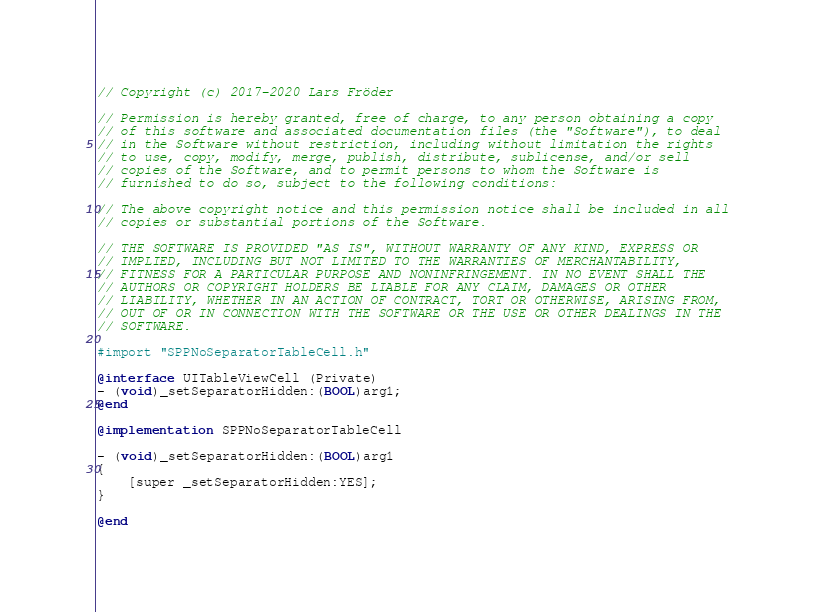Convert code to text. <code><loc_0><loc_0><loc_500><loc_500><_ObjectiveC_>// Copyright (c) 2017-2020 Lars Fröder

// Permission is hereby granted, free of charge, to any person obtaining a copy
// of this software and associated documentation files (the "Software"), to deal
// in the Software without restriction, including without limitation the rights
// to use, copy, modify, merge, publish, distribute, sublicense, and/or sell
// copies of the Software, and to permit persons to whom the Software is
// furnished to do so, subject to the following conditions:

// The above copyright notice and this permission notice shall be included in all
// copies or substantial portions of the Software.

// THE SOFTWARE IS PROVIDED "AS IS", WITHOUT WARRANTY OF ANY KIND, EXPRESS OR
// IMPLIED, INCLUDING BUT NOT LIMITED TO THE WARRANTIES OF MERCHANTABILITY,
// FITNESS FOR A PARTICULAR PURPOSE AND NONINFRINGEMENT. IN NO EVENT SHALL THE
// AUTHORS OR COPYRIGHT HOLDERS BE LIABLE FOR ANY CLAIM, DAMAGES OR OTHER
// LIABILITY, WHETHER IN AN ACTION OF CONTRACT, TORT OR OTHERWISE, ARISING FROM,
// OUT OF OR IN CONNECTION WITH THE SOFTWARE OR THE USE OR OTHER DEALINGS IN THE
// SOFTWARE.

#import "SPPNoSeparatorTableCell.h"

@interface UITableViewCell (Private)
- (void)_setSeparatorHidden:(BOOL)arg1;
@end

@implementation SPPNoSeparatorTableCell

- (void)_setSeparatorHidden:(BOOL)arg1
{
	[super _setSeparatorHidden:YES];
}

@end
</code> 